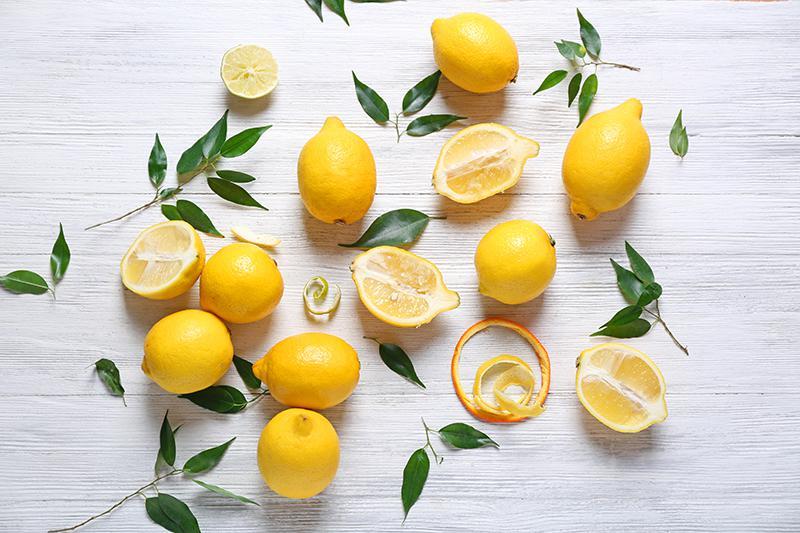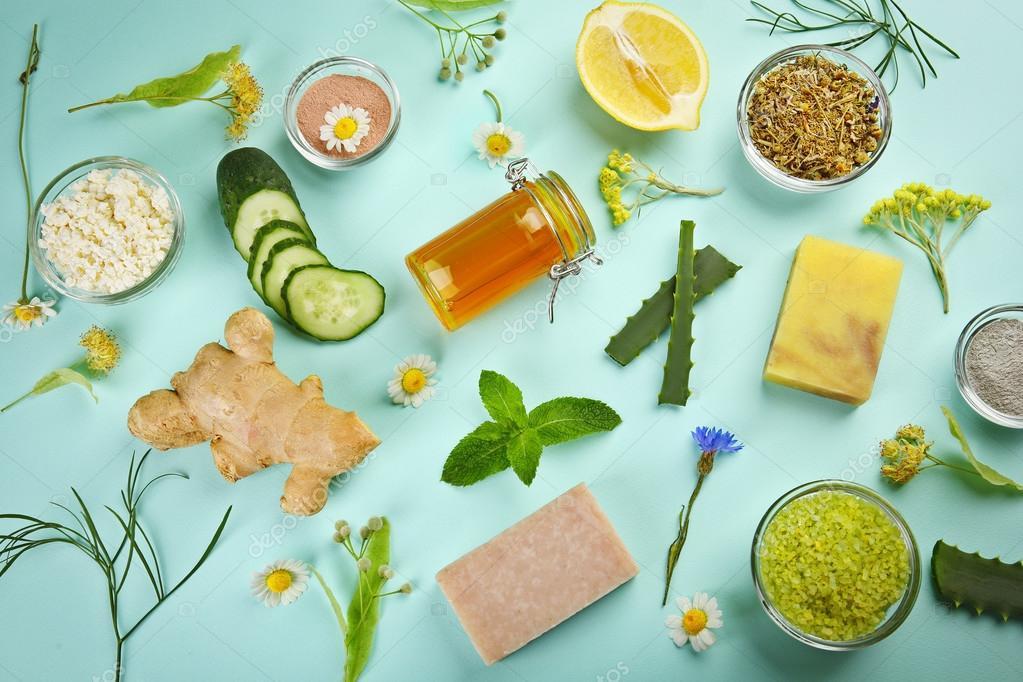The first image is the image on the left, the second image is the image on the right. For the images shown, is this caption "One spoon is resting in a bowl of food containing lemons." true? Answer yes or no. No. The first image is the image on the left, the second image is the image on the right. Evaluate the accuracy of this statement regarding the images: "One image features a scattered display on a painted wood surface that includes whole lemons, cut lemons, and green leaves.". Is it true? Answer yes or no. Yes. 